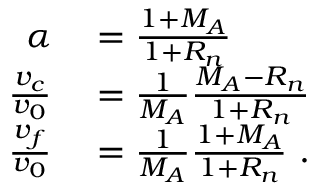<formula> <loc_0><loc_0><loc_500><loc_500>\begin{array} { r l } { \alpha } & = \frac { 1 + M _ { A } } { 1 + R _ { n } } } \\ { \frac { v _ { c } } { v _ { 0 } } } & = \frac { 1 } { M _ { A } } \frac { M _ { A } - R _ { n } } { 1 + R _ { n } } } \\ { \frac { v _ { f } } { v _ { 0 } } } & = \frac { 1 } { M _ { A } } \frac { 1 + M _ { A } } { 1 + R _ { n } } \ . } \end{array}</formula> 